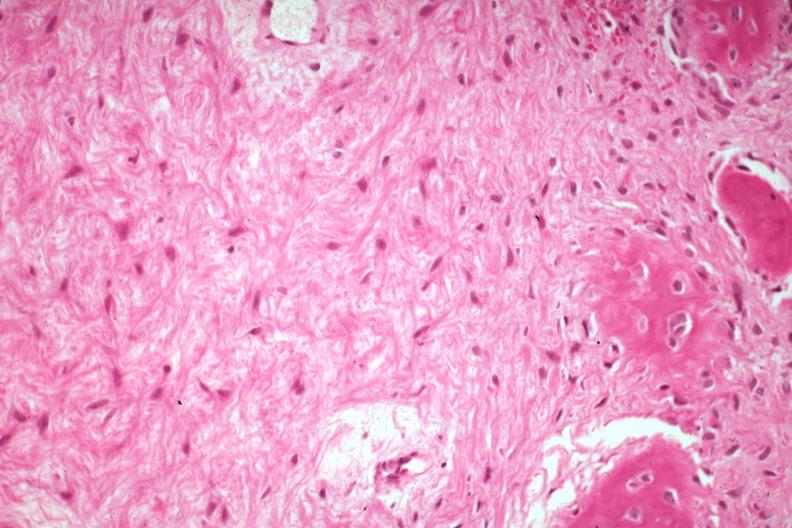what does this image show?
Answer the question using a single word or phrase. High good example bone formation with osteoid and osteoblasts 